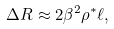<formula> <loc_0><loc_0><loc_500><loc_500>\Delta R \approx 2 \beta ^ { 2 } \rho ^ { * } \ell ,</formula> 